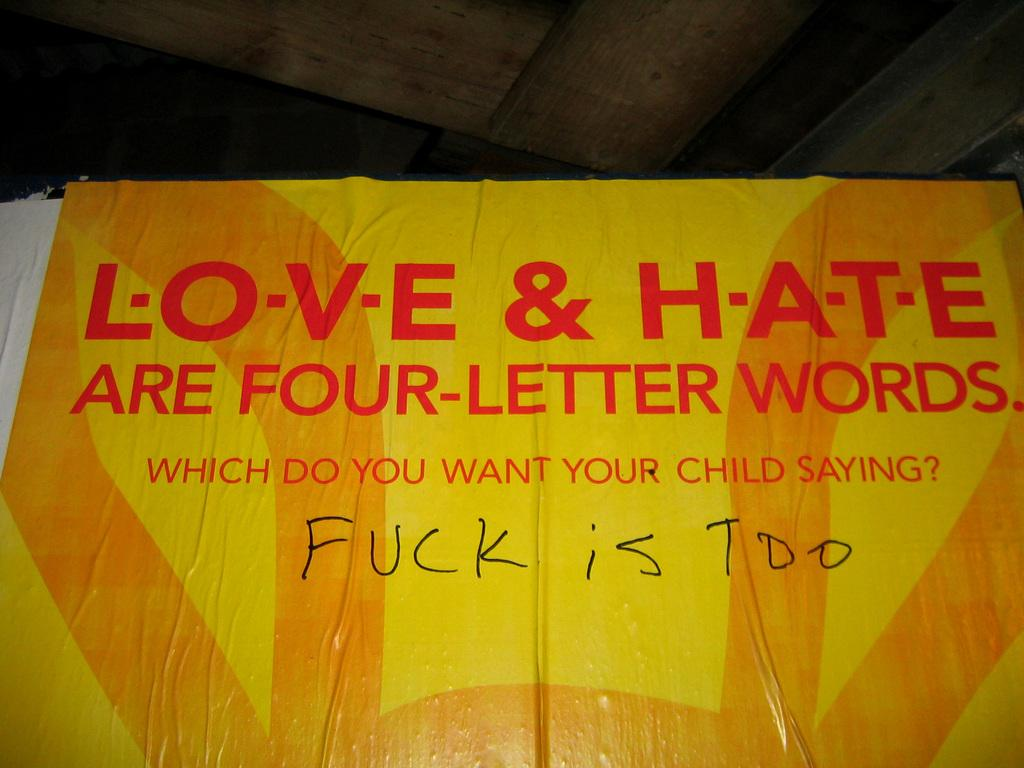What is located in the foreground of the image? There is a banner with text in the foreground of the image. What type of structure can be seen in the image? There is a roof visible in the image. What type of body is visible in the image? There is no body visible in the image; it only features a banner with text and a roof. What type of kite can be seen flying in the image? There is no kite present in the image. 